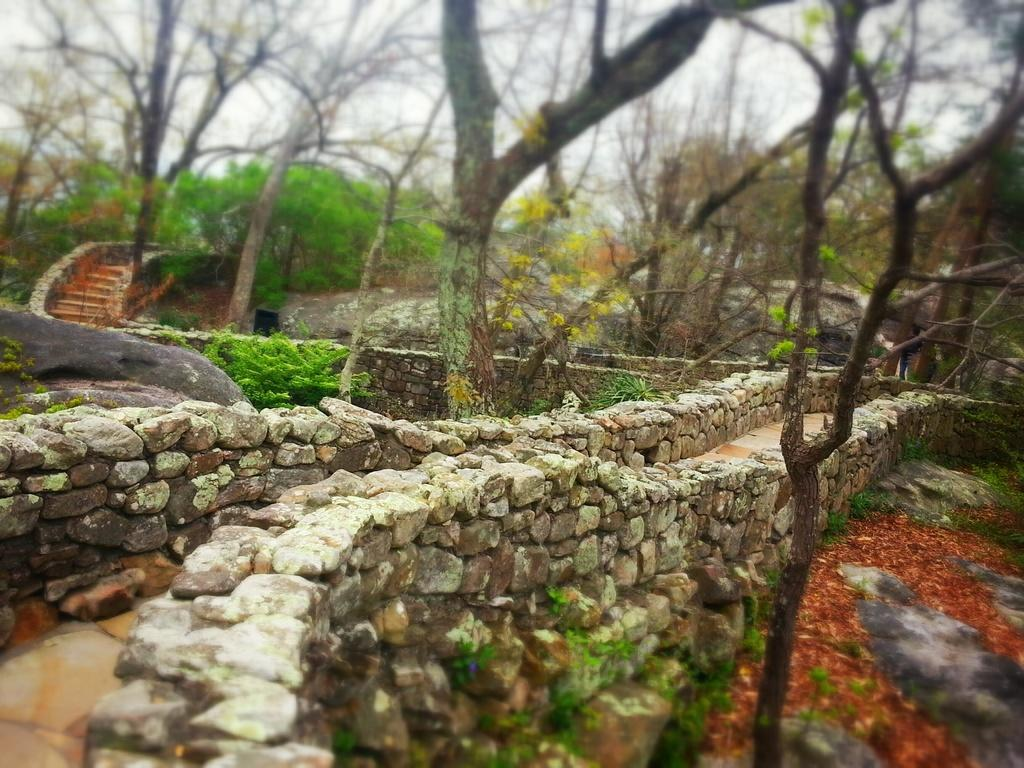What type of structure is at the bottom of the image? There is a stone wall at the bottom of the image. What can be seen in the background of the image? There are trees in the background of the image. Where are the stairs located in the image? The stairs are on the left side of the image. Can you see a frog jumping on the stone wall in the image? There is no frog present in the image; it only features a stone wall, trees in the background, and stairs on the left side. Is there a room visible in the image? The image does not show any rooms; it only contains a stone wall, trees, and stairs. 